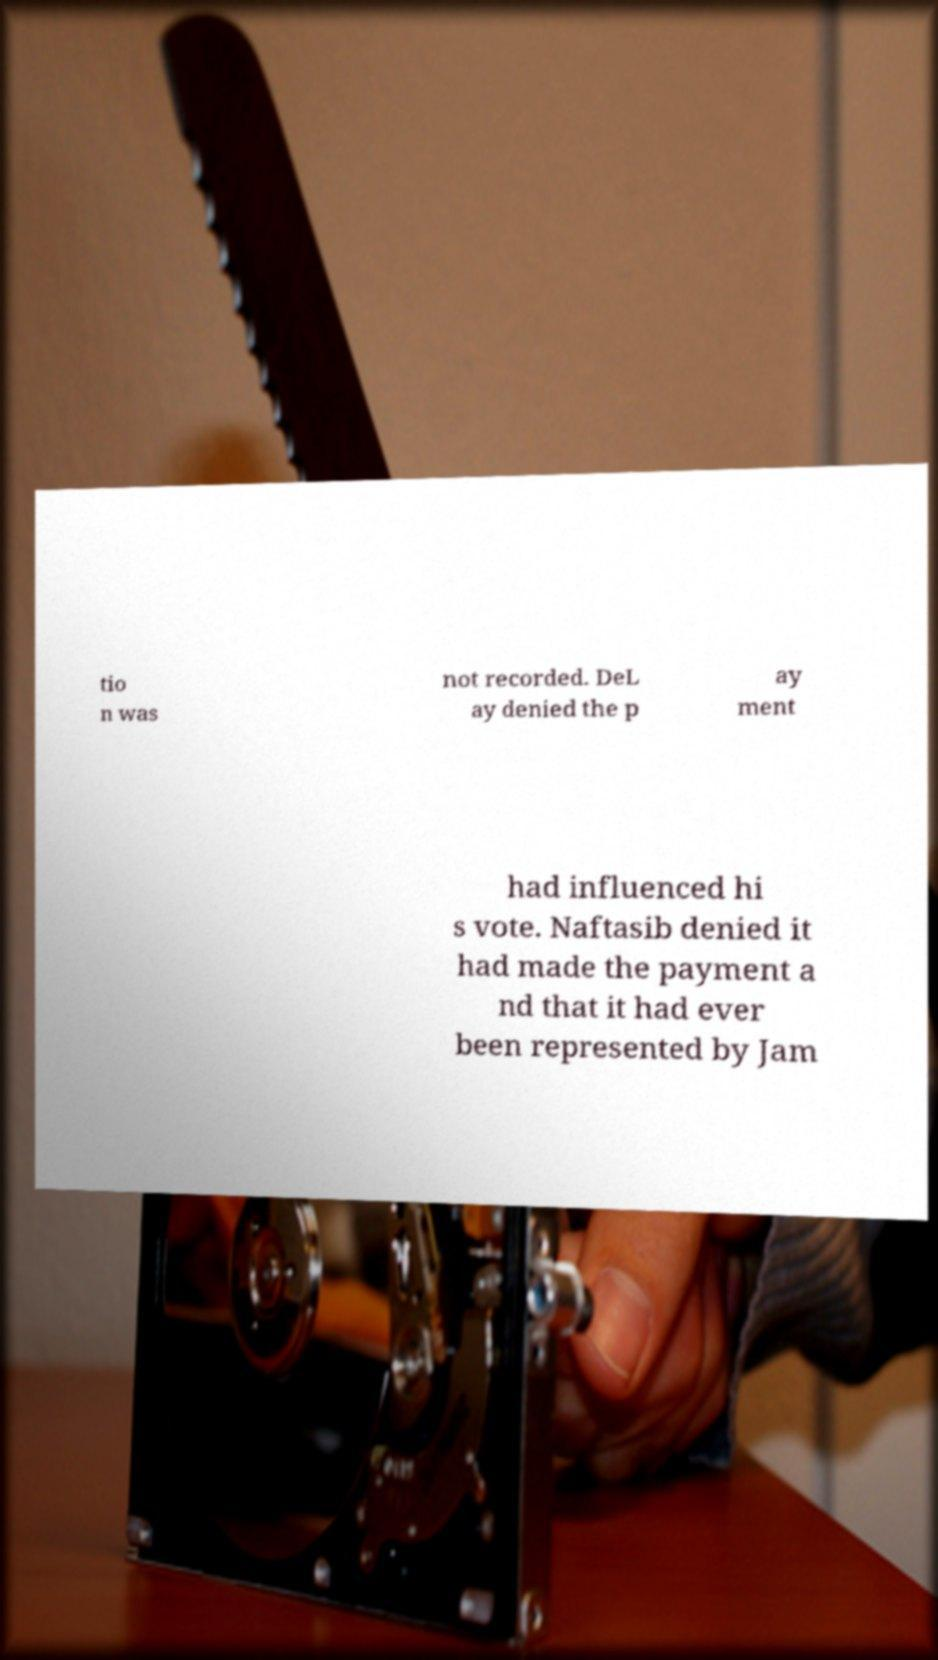What messages or text are displayed in this image? I need them in a readable, typed format. tio n was not recorded. DeL ay denied the p ay ment had influenced hi s vote. Naftasib denied it had made the payment a nd that it had ever been represented by Jam 